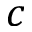<formula> <loc_0><loc_0><loc_500><loc_500>c</formula> 